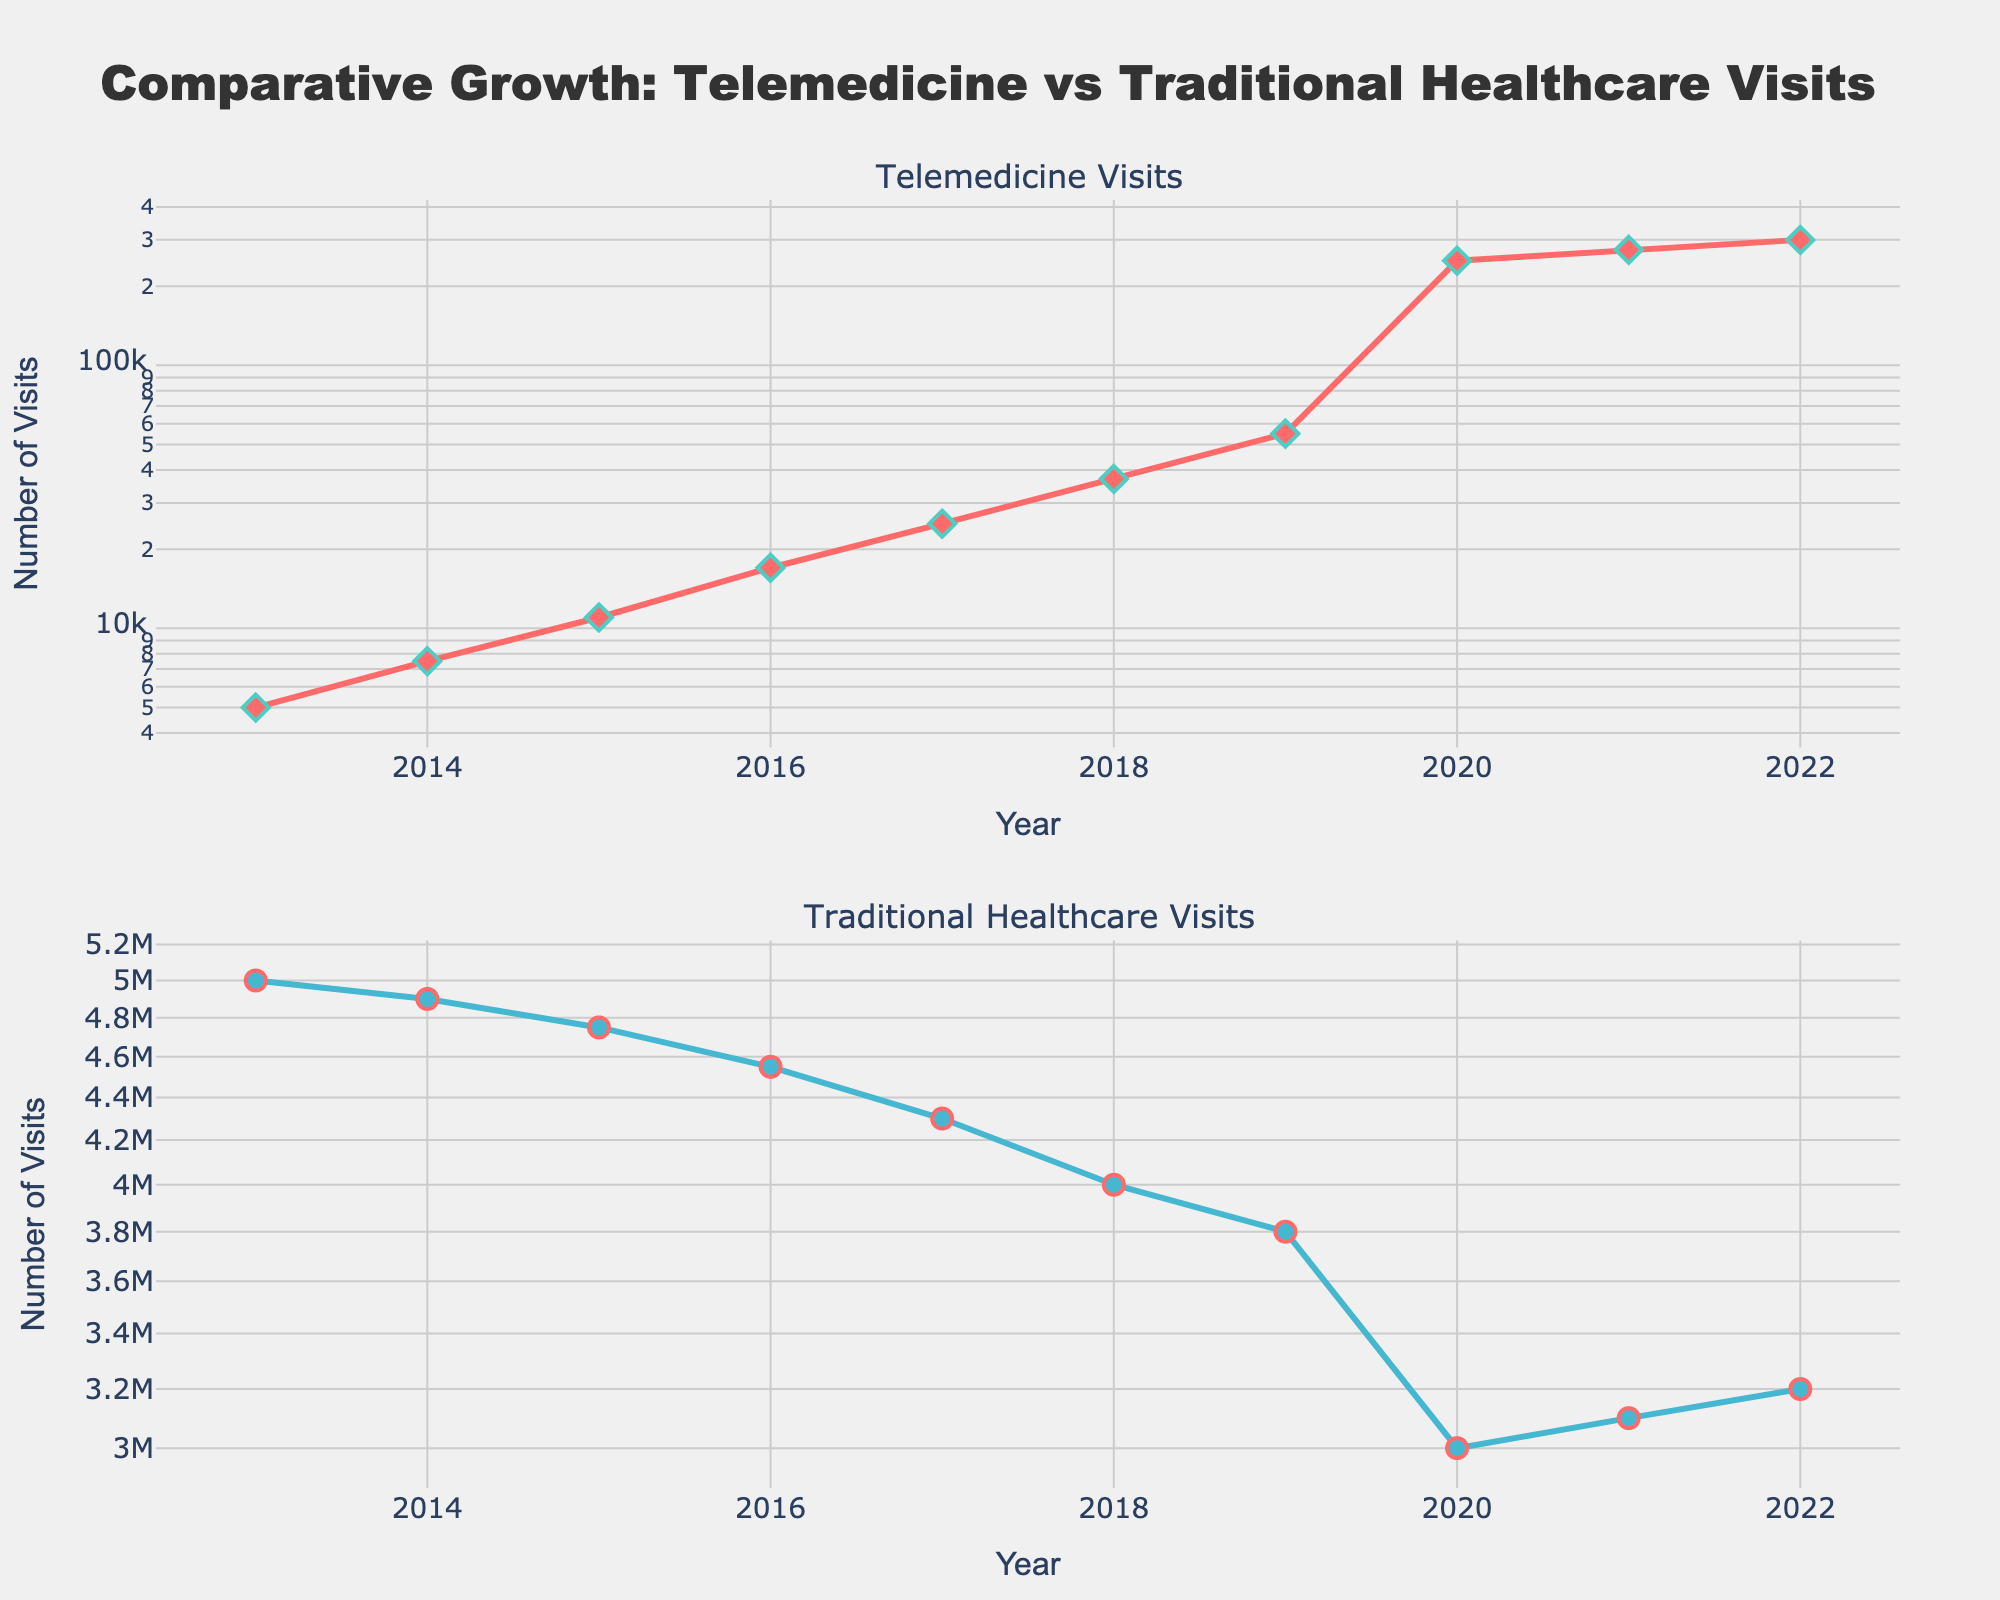What's the title of the figure? The title is located at the top center of the figure. It provides a summary of what the figure represents.
Answer: Comparative Growth: Telemedicine vs Traditional Healthcare Visits How many data points are plotted for Telemedicine Visits? Look at the number of markers (diamonds) in the first subplot. Each marker represents a data point for a specific year.
Answer: 10 What is the minimum number of Traditional Healthcare Visits recorded in the given years? Observe the lowest point on the y-axis in the second subplot; align it with the year.
Answer: 3,000,000 How does the number of Telemedicine Visits in 2018 compare to the number in 2020? Locate the data points for 2018 and 2020 in the first subplot. Compare the y-values (number of visits) for these years.
Answer: 2020 is significantly higher than 2018 What trend do you observe in Telemedicine Visits over the plotted years? Examine the first subplot's curve. The general direction and change over the years illustrate the trend.
Answer: Steep increase, especially from 2019 to 2020 How did Traditional Healthcare Visits change from 2013 to 2020? Observe the second subplot. Note the change in y-values from the start (2013) to the end (2020).
Answer: Decreasing trend What is the logarithmic growth pattern indicated by the plot for both types of healthcare visits? Both subplots use a logarithmic scale on the y-axis. Note how the values increase or decrease geometrically rather than linearly over the years.
Answer: Exponential growth for Telemedicine, slight exponential decline for Traditional Healthcare What are the years in which Telemedicine Visits had significant jumps? By observing the first subplot, identify the years where there are noticeable spikes in the y-values.
Answer: 2020, 2021 Which year had the highest number of Traditional Healthcare Visits? Find the highest point on the y-axis in the second subplot and align it with the corresponding year.
Answer: 2013 In which year did Telemedicine Visits first exceed 100,000? Identify the data point in the first subplot where the y-value first crosses 100,000.
Answer: 2020 